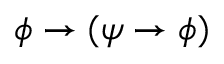Convert formula to latex. <formula><loc_0><loc_0><loc_500><loc_500>\phi \to ( \psi \to \phi )</formula> 